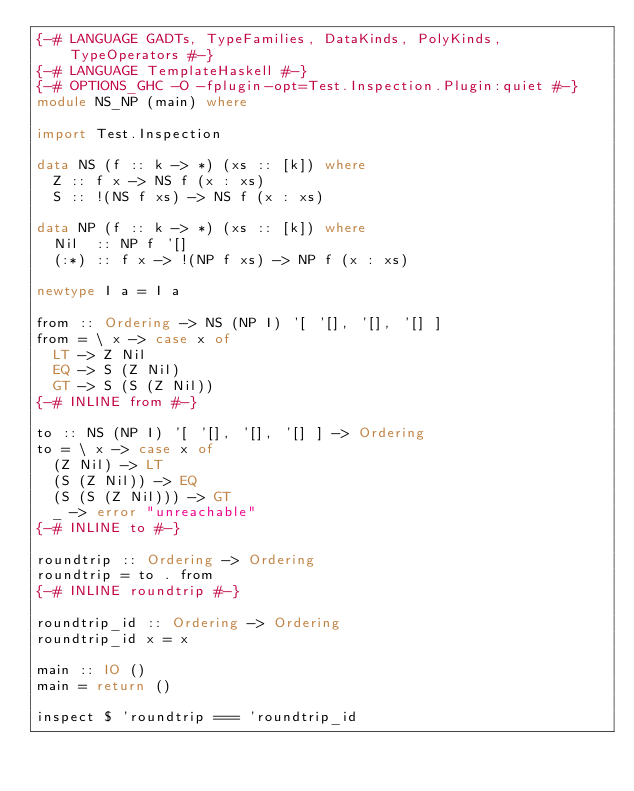Convert code to text. <code><loc_0><loc_0><loc_500><loc_500><_Haskell_>{-# LANGUAGE GADTs, TypeFamilies, DataKinds, PolyKinds, TypeOperators #-}
{-# LANGUAGE TemplateHaskell #-}
{-# OPTIONS_GHC -O -fplugin-opt=Test.Inspection.Plugin:quiet #-}
module NS_NP (main) where

import Test.Inspection

data NS (f :: k -> *) (xs :: [k]) where
  Z :: f x -> NS f (x : xs)
  S :: !(NS f xs) -> NS f (x : xs)

data NP (f :: k -> *) (xs :: [k]) where
  Nil  :: NP f '[]
  (:*) :: f x -> !(NP f xs) -> NP f (x : xs)

newtype I a = I a

from :: Ordering -> NS (NP I) '[ '[], '[], '[] ]
from = \ x -> case x of
  LT -> Z Nil
  EQ -> S (Z Nil)
  GT -> S (S (Z Nil))
{-# INLINE from #-}

to :: NS (NP I) '[ '[], '[], '[] ] -> Ordering
to = \ x -> case x of
  (Z Nil) -> LT
  (S (Z Nil)) -> EQ
  (S (S (Z Nil))) -> GT
  _ -> error "unreachable"
{-# INLINE to #-}

roundtrip :: Ordering -> Ordering
roundtrip = to . from
{-# INLINE roundtrip #-}

roundtrip_id :: Ordering -> Ordering
roundtrip_id x = x

main :: IO ()
main = return ()

inspect $ 'roundtrip === 'roundtrip_id
</code> 